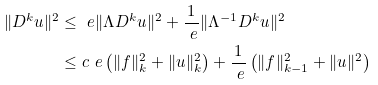Convert formula to latex. <formula><loc_0><loc_0><loc_500><loc_500>\| D ^ { k } u \| ^ { 2 } & \leq \ e \| \Lambda D ^ { k } u \| ^ { 2 } + \frac { 1 } { \ e } \| \Lambda ^ { - 1 } D ^ { k } u \| ^ { 2 } \\ & \leq c \ e \left ( \| f \| _ { k } ^ { 2 } + \| u \| _ { k } ^ { 2 } \right ) + \frac { 1 } { \ e } \left ( \| f \| _ { k - 1 } ^ { 2 } + \| u \| ^ { 2 } \right )</formula> 